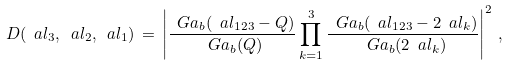<formula> <loc_0><loc_0><loc_500><loc_500>D ( \ a l _ { 3 } , \ a l _ { 2 } , \ a l _ { 1 } ) \, = \, \left | \frac { \ G a _ { b } ( \ a l _ { 1 2 3 } - Q ) } { \ G a _ { b } ( Q ) } \prod _ { k = 1 } ^ { 3 } \frac { \ G a _ { b } ( \ a l _ { 1 2 3 } - 2 \ a l _ { k } ) } { \ G a _ { b } ( 2 \ a l _ { k } ) } \right | ^ { 2 } \, ,</formula> 